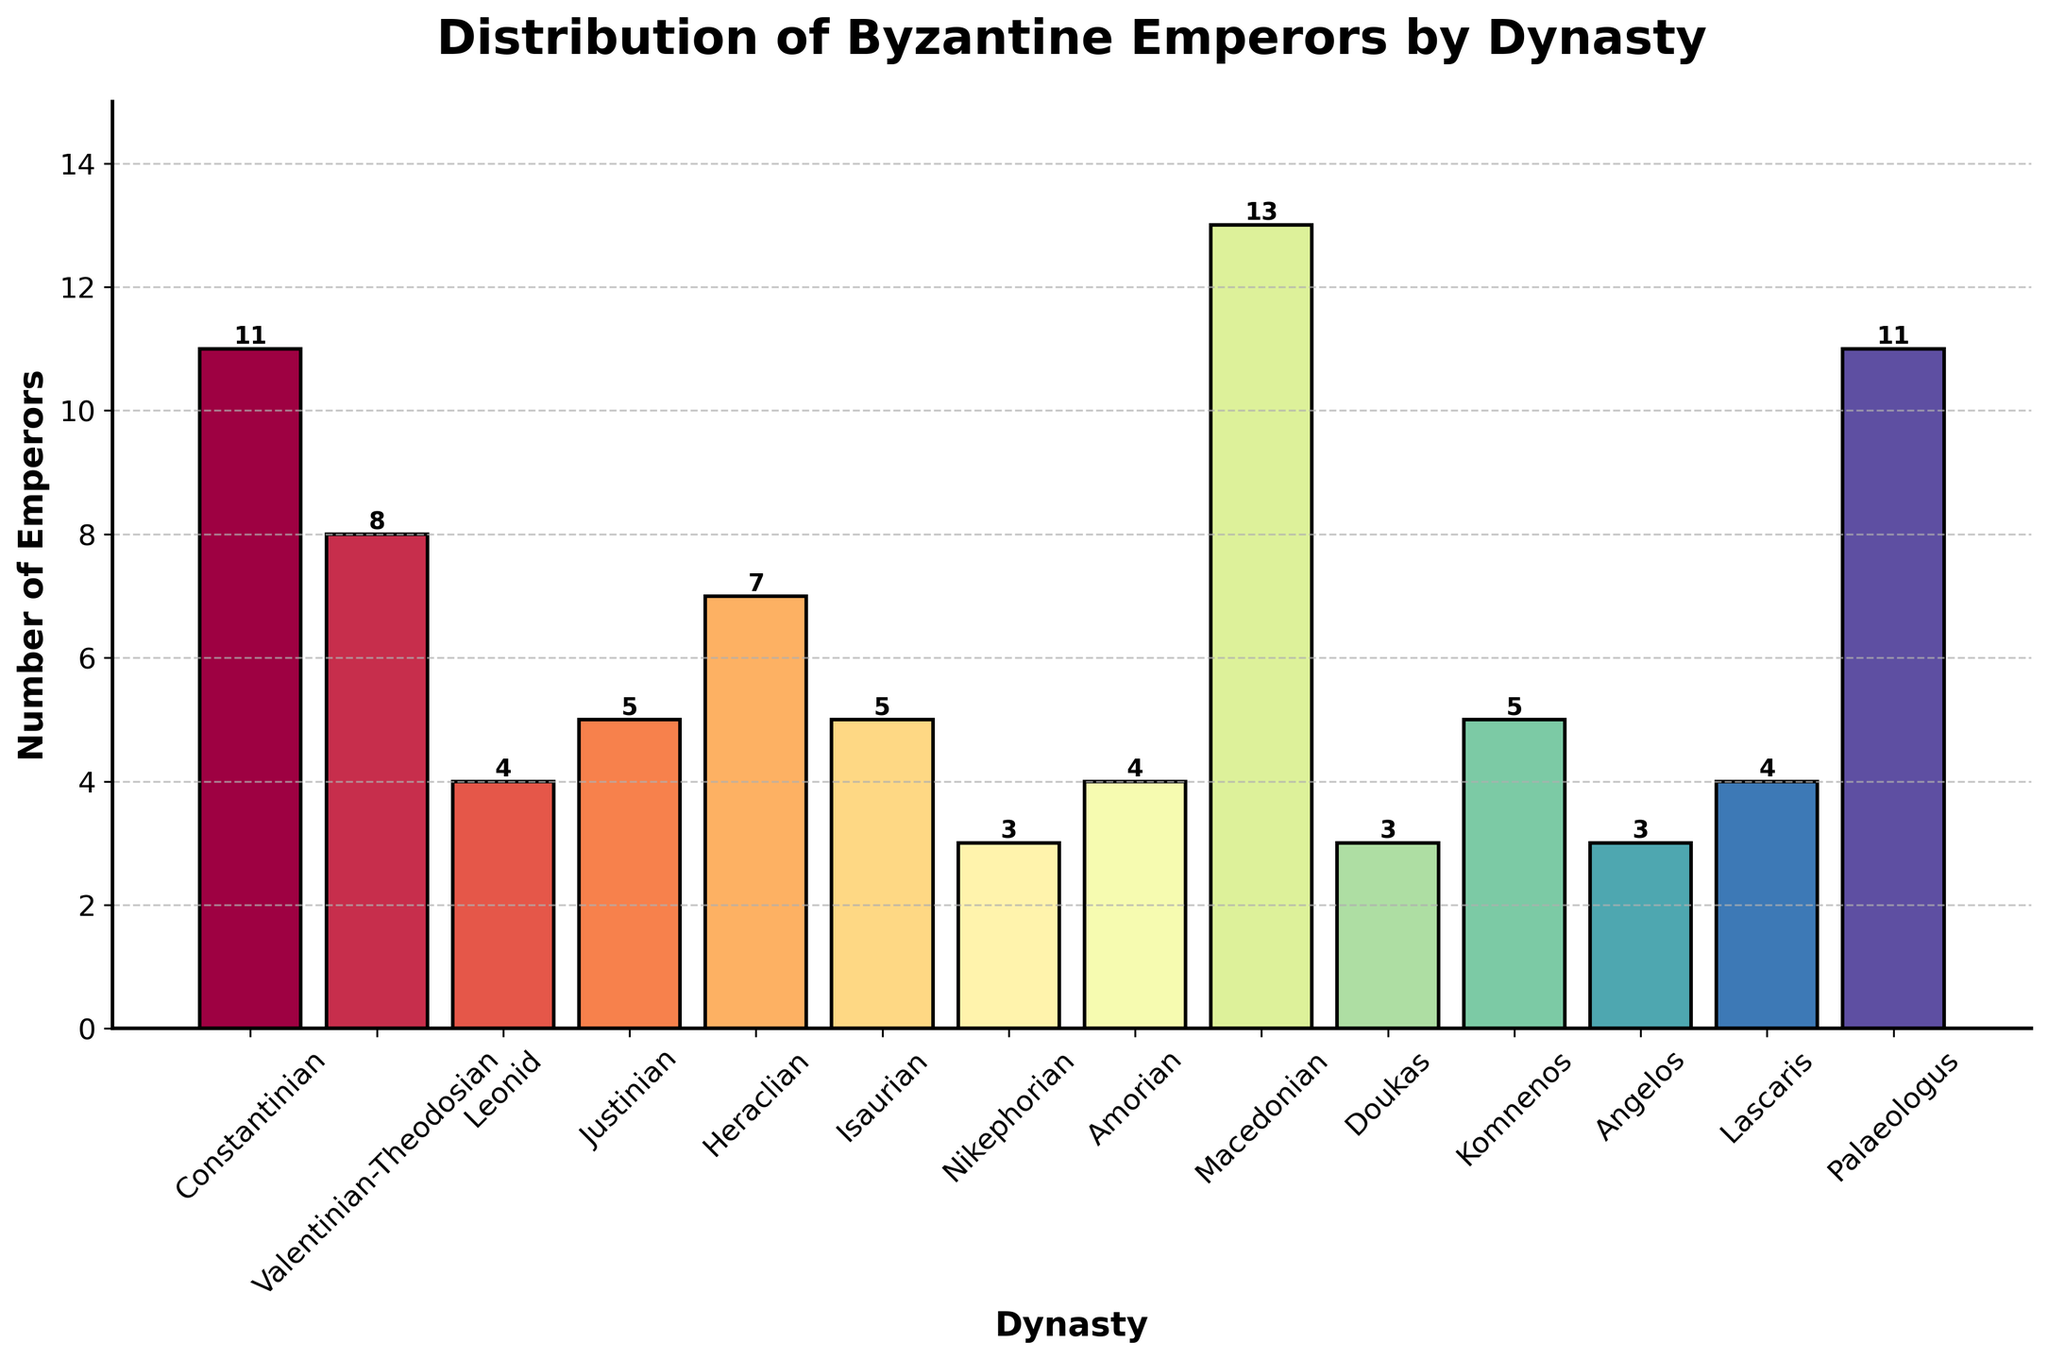Which dynasty had the highest number of emperors? To find this, look at the height of all the bars and identify the tallest one. The Macedonian dynasty has the most emperors with a bar that reaches the highest point.
Answer: Macedonian How many more emperors did the Macedonian dynasty have compared to the Komnenos dynasty? The number of emperors for the Macedonian dynasty is 13, and for the Komnenos dynasty, it is 5. The difference is calculated as 13 - 5.
Answer: 8 Which two dynasties had an equal number of emperors? Look for bars of the same height. The Isaurian and Justinian dynasties each have bars reaching the height of 5 emperors.
Answer: Isaurian and Justinian What is the combined number of emperors from the Anglos and Doukas dynasties? Add the number of emperors from the Anglos dynasty (3) and the Doukas dynasty (3). The combined number is 3+3.
Answer: 6 Which dynasty had fewer emperors: the Nikephorian or the Leonid? Compare the heights of the bars for the Nikephorian and Leonid dynasties. The Nikephorian dynasty has 3 emperors while the Leonid has 4.
Answer: Nikephorian What is the average number of emperors per dynasty? To find the average, sum the number of emperors from all dynasties and divide by the number of dynasties. The total number of emperors is 86 (11+8+4+5+7+5+3+4+13+3+5+3+4+11) and the number of dynasties is 14. The average is 86/14.
Answer: 6.14 How many dynasties had more than 10 emperors? Count the bars with a height greater than 10. The dynasties are Constantinian (11), Macedonian (13), and Palaeologus (11).
Answer: 3 Which dynasty had the exact number of emperors as the Valentinian-Theodosian and Heraclian dynasties combined? Sum the emperors of the Valentinian-Theodosian (8) and Heraclian (7) dynasties, which is 8+7=15. None of the dynasties in the chart have 15 emperors.
Answer: None Which color represents the Leonid dynasty? Observe the bar corresponding to the Leonid dynasty, positioned third from the left. Describe its color.
Answer: Light green/navy What is the difference between the number of emperors from the Heraclian and Isaurian dynasties? The number of emperors for the Heraclian dynasty is 7 and for the Isaurian dynasty is 5. The difference is 7 - 5.
Answer: 2 